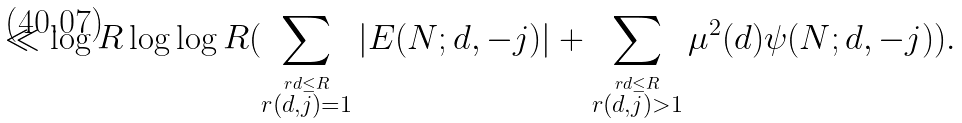Convert formula to latex. <formula><loc_0><loc_0><loc_500><loc_500>\ll \log R \log \log R ( \sum _ { \stackrel { r d \leq R } { r ( d , j ) = 1 } } | E ( N ; d , - j ) | + \sum _ { \stackrel { r d \leq R } { r ( d , j ) > 1 } } \mu ^ { 2 } ( d ) \psi ( N ; d , - j ) ) .</formula> 